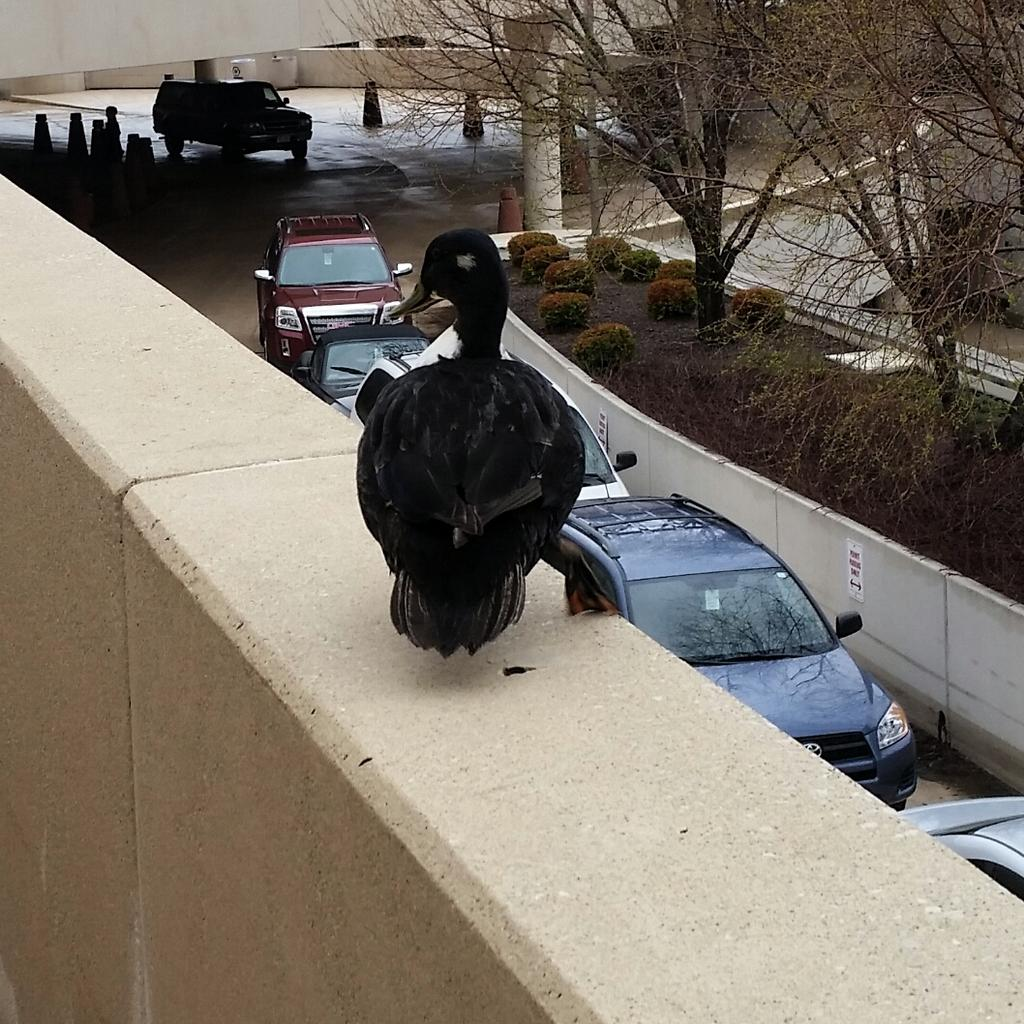What is standing on the wall in the image? There is a bird standing on the wall in the image. What can be seen on the pavement in the image? There are vehicles on the pavement in the image. What type of vegetation is present in the image? There are plants and trees in the image. What color is the knee of the bird in the image? Birds do not have knees like humans, and there is no mention of a knee in the image. How does the throat of the bird in the image look? There is no mention of a throat in the image, and it is not possible to see the internal anatomy of the bird. 